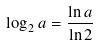<formula> <loc_0><loc_0><loc_500><loc_500>\log _ { 2 } a = \frac { \ln a } { \ln 2 }</formula> 